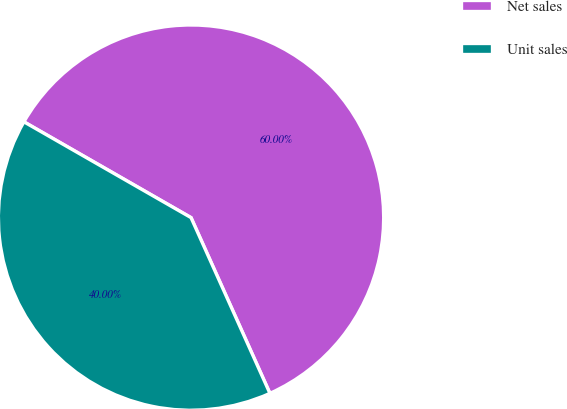Convert chart to OTSL. <chart><loc_0><loc_0><loc_500><loc_500><pie_chart><fcel>Net sales<fcel>Unit sales<nl><fcel>60.0%<fcel>40.0%<nl></chart> 